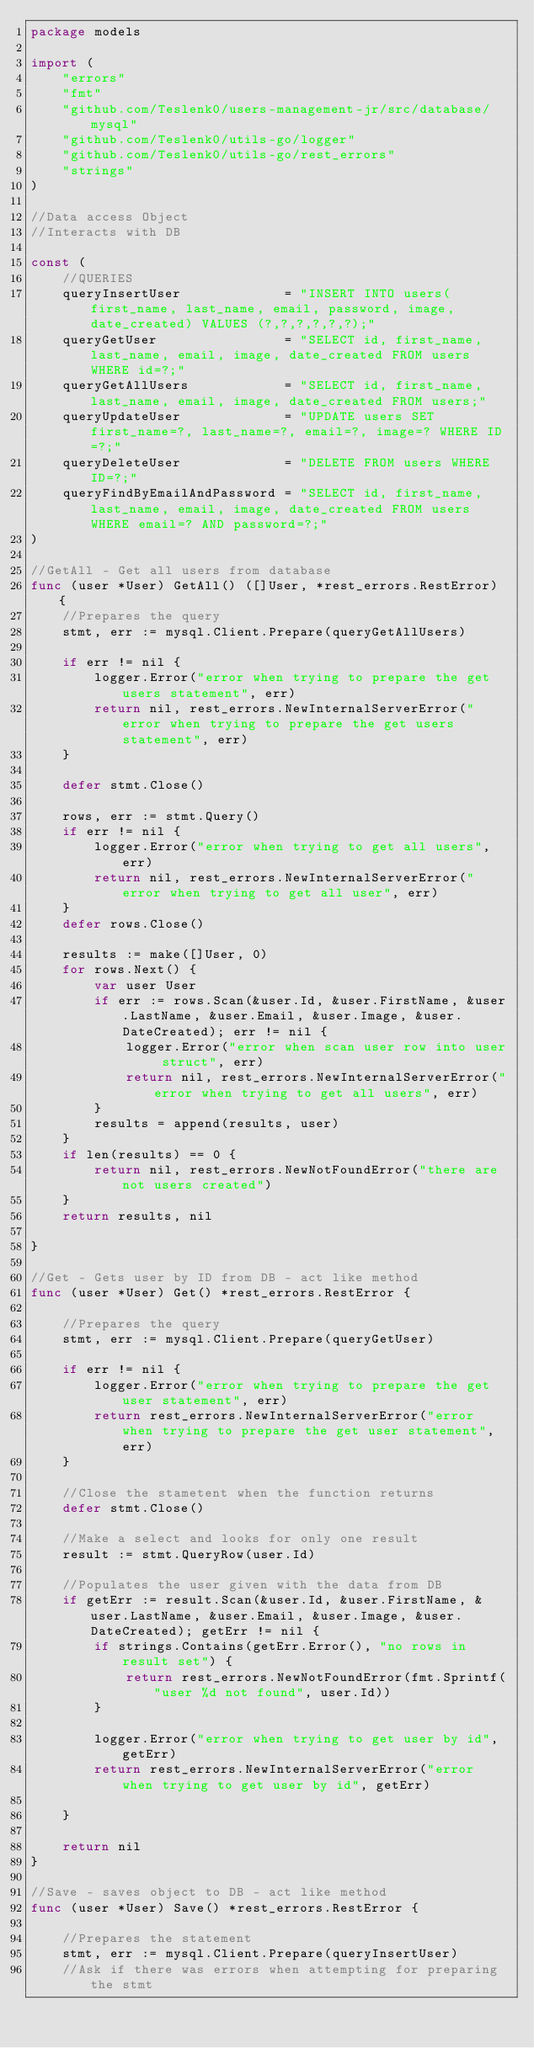Convert code to text. <code><loc_0><loc_0><loc_500><loc_500><_Go_>package models

import (
	"errors"
	"fmt"
	"github.com/Teslenk0/users-management-jr/src/database/mysql"
	"github.com/Teslenk0/utils-go/logger"
	"github.com/Teslenk0/utils-go/rest_errors"
	"strings"
)

//Data access Object
//Interacts with DB

const (
	//QUERIES
	queryInsertUser             = "INSERT INTO users(first_name, last_name, email, password, image, date_created) VALUES (?,?,?,?,?,?);"
	queryGetUser                = "SELECT id, first_name, last_name, email, image, date_created FROM users WHERE id=?;"
	queryGetAllUsers            = "SELECT id, first_name, last_name, email, image, date_created FROM users;"
	queryUpdateUser             = "UPDATE users SET first_name=?, last_name=?, email=?, image=? WHERE ID=?;"
	queryDeleteUser             = "DELETE FROM users WHERE ID=?;"
	queryFindByEmailAndPassword = "SELECT id, first_name, last_name, email, image, date_created FROM users WHERE email=? AND password=?;"
)

//GetAll - Get all users from database
func (user *User) GetAll() ([]User, *rest_errors.RestError) {
	//Prepares the query
	stmt, err := mysql.Client.Prepare(queryGetAllUsers)

	if err != nil {
		logger.Error("error when trying to prepare the get users statement", err)
		return nil, rest_errors.NewInternalServerError("error when trying to prepare the get users statement", err)
	}

	defer stmt.Close()

	rows, err := stmt.Query()
	if err != nil {
		logger.Error("error when trying to get all users", err)
		return nil, rest_errors.NewInternalServerError("error when trying to get all user", err)
	}
	defer rows.Close()

	results := make([]User, 0)
	for rows.Next() {
		var user User
		if err := rows.Scan(&user.Id, &user.FirstName, &user.LastName, &user.Email, &user.Image, &user.DateCreated); err != nil {
			logger.Error("error when scan user row into user struct", err)
			return nil, rest_errors.NewInternalServerError("error when trying to get all users", err)
		}
		results = append(results, user)
	}
	if len(results) == 0 {
		return nil, rest_errors.NewNotFoundError("there are not users created")
	}
	return results, nil

}

//Get - Gets user by ID from DB - act like method
func (user *User) Get() *rest_errors.RestError {

	//Prepares the query
	stmt, err := mysql.Client.Prepare(queryGetUser)

	if err != nil {
		logger.Error("error when trying to prepare the get user statement", err)
		return rest_errors.NewInternalServerError("error when trying to prepare the get user statement", err)
	}

	//Close the stametent when the function returns
	defer stmt.Close()

	//Make a select and looks for only one result
	result := stmt.QueryRow(user.Id)

	//Populates the user given with the data from DB
	if getErr := result.Scan(&user.Id, &user.FirstName, &user.LastName, &user.Email, &user.Image, &user.DateCreated); getErr != nil {
		if strings.Contains(getErr.Error(), "no rows in result set") {
			return rest_errors.NewNotFoundError(fmt.Sprintf("user %d not found", user.Id))
		}

		logger.Error("error when trying to get user by id", getErr)
		return rest_errors.NewInternalServerError("error when trying to get user by id", getErr)

	}

	return nil
}

//Save - saves object to DB - act like method
func (user *User) Save() *rest_errors.RestError {

	//Prepares the statement
	stmt, err := mysql.Client.Prepare(queryInsertUser)
	//Ask if there was errors when attempting for preparing the stmt</code> 